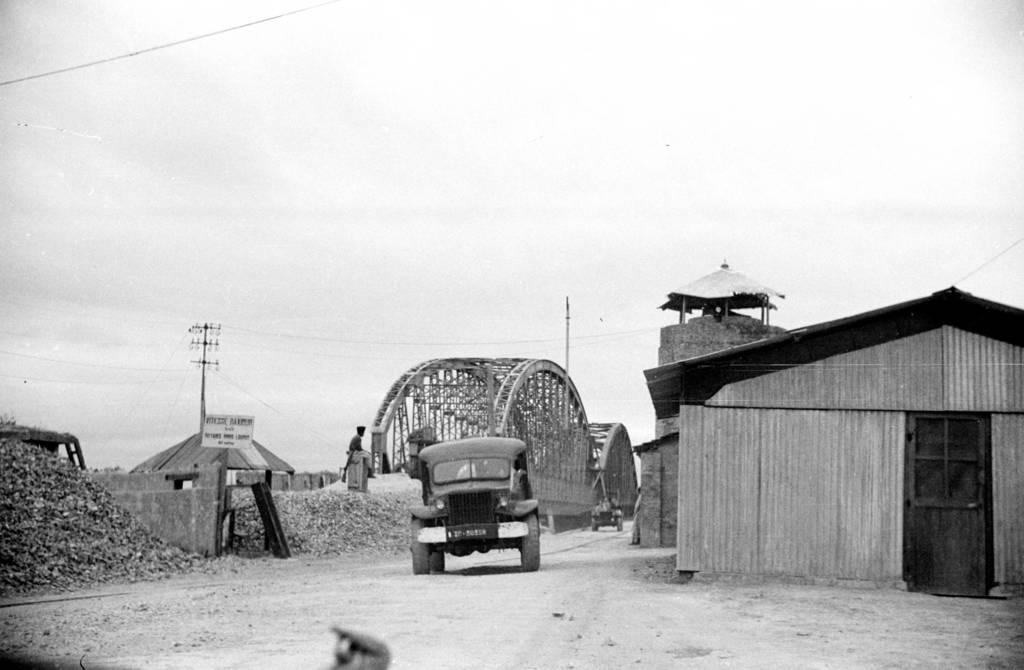What is on the road in the image? There is a vehicle on the road in the image. What structure is located on the right side of the image? There is a house on the right side of the image. Where is the boy sitting in the image? The boy is sitting on the left side of the image. What type of ice can be seen melting in the image? There is no ice present in the image. Is there a battle taking place in the image? There is no battle depicted in the image. 